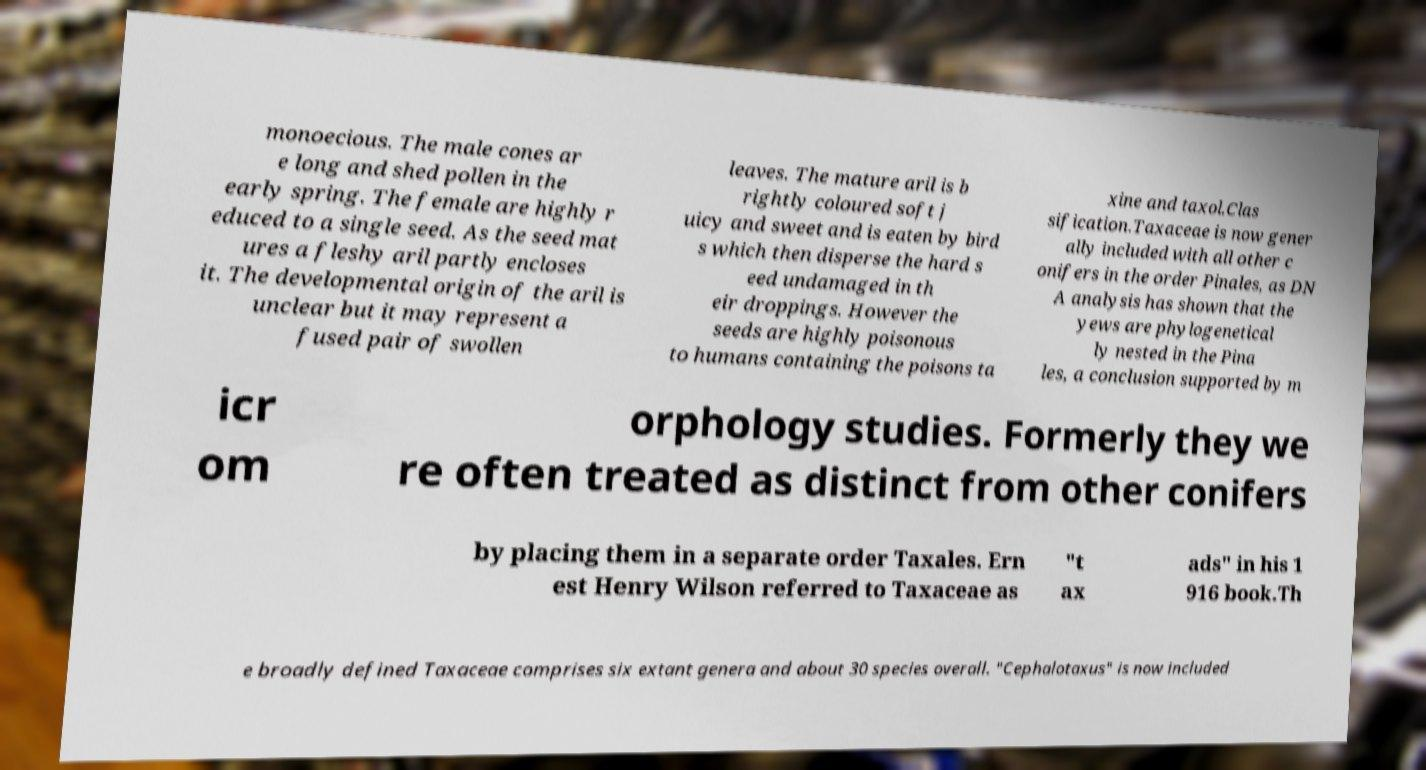Please identify and transcribe the text found in this image. monoecious. The male cones ar e long and shed pollen in the early spring. The female are highly r educed to a single seed. As the seed mat ures a fleshy aril partly encloses it. The developmental origin of the aril is unclear but it may represent a fused pair of swollen leaves. The mature aril is b rightly coloured soft j uicy and sweet and is eaten by bird s which then disperse the hard s eed undamaged in th eir droppings. However the seeds are highly poisonous to humans containing the poisons ta xine and taxol.Clas sification.Taxaceae is now gener ally included with all other c onifers in the order Pinales, as DN A analysis has shown that the yews are phylogenetical ly nested in the Pina les, a conclusion supported by m icr om orphology studies. Formerly they we re often treated as distinct from other conifers by placing them in a separate order Taxales. Ern est Henry Wilson referred to Taxaceae as "t ax ads" in his 1 916 book.Th e broadly defined Taxaceae comprises six extant genera and about 30 species overall. "Cephalotaxus" is now included 